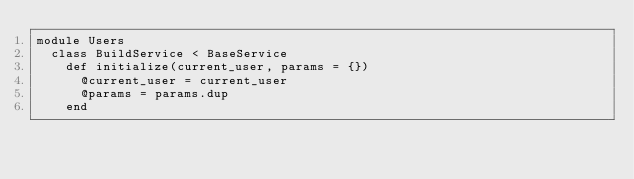Convert code to text. <code><loc_0><loc_0><loc_500><loc_500><_Ruby_>module Users
  class BuildService < BaseService
    def initialize(current_user, params = {})
      @current_user = current_user
      @params = params.dup
    end
</code> 